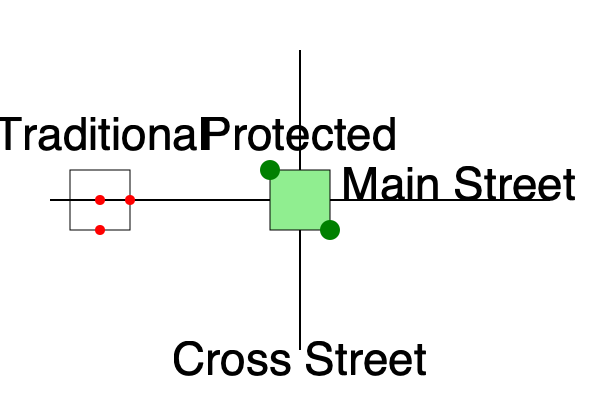Based on the collision diagram showing a traditional intersection and a protected intersection design, which design is likely to have a greater positive impact on cyclist safety, and why? Quantify the difference in potential conflict points between the two designs. To analyze the impact of different intersection designs on cyclist safety, we need to consider the number of potential conflict points between cyclists and vehicles. Let's examine each design:

1. Traditional Intersection:
   - This design shows 3 red dots, representing potential conflict points.
   - These typically occur where cyclist paths intersect with turning vehicles.
   - Conflict points: right turns, left turns, and through movements.

2. Protected Intersection:
   - This design shows green areas, representing protective islands for cyclists.
   - No visible red dots, indicating a significant reduction in conflict points.
   - Cyclists are separated from vehicle traffic until they enter the intersection.

To quantify the difference:
- Traditional Intersection: 3 conflict points
- Protected Intersection: 0 visible conflict points

Difference in conflict points = 3 - 0 = 3

The protected intersection design is likely to have a greater positive impact on cyclist safety for the following reasons:

1. Reduced conflict points: Eliminates or significantly reduces direct interactions between cyclists and vehicles.
2. Improved visibility: The protective islands create a space where cyclists and drivers can see each other before potential conflicts.
3. Decreased exposure time: Cyclists spend less time in areas where they might interact with vehicles.
4. Lower speeds: The design encourages vehicles to make slower turns, reducing the severity of potential collisions.

The quantitative difference of 3 fewer conflict points in the protected design represents a substantial improvement in safety. Each conflict point removed reduces the probability of a collision, thus enhancing overall cyclist safety at the intersection.
Answer: Protected intersection; 3 fewer conflict points. 